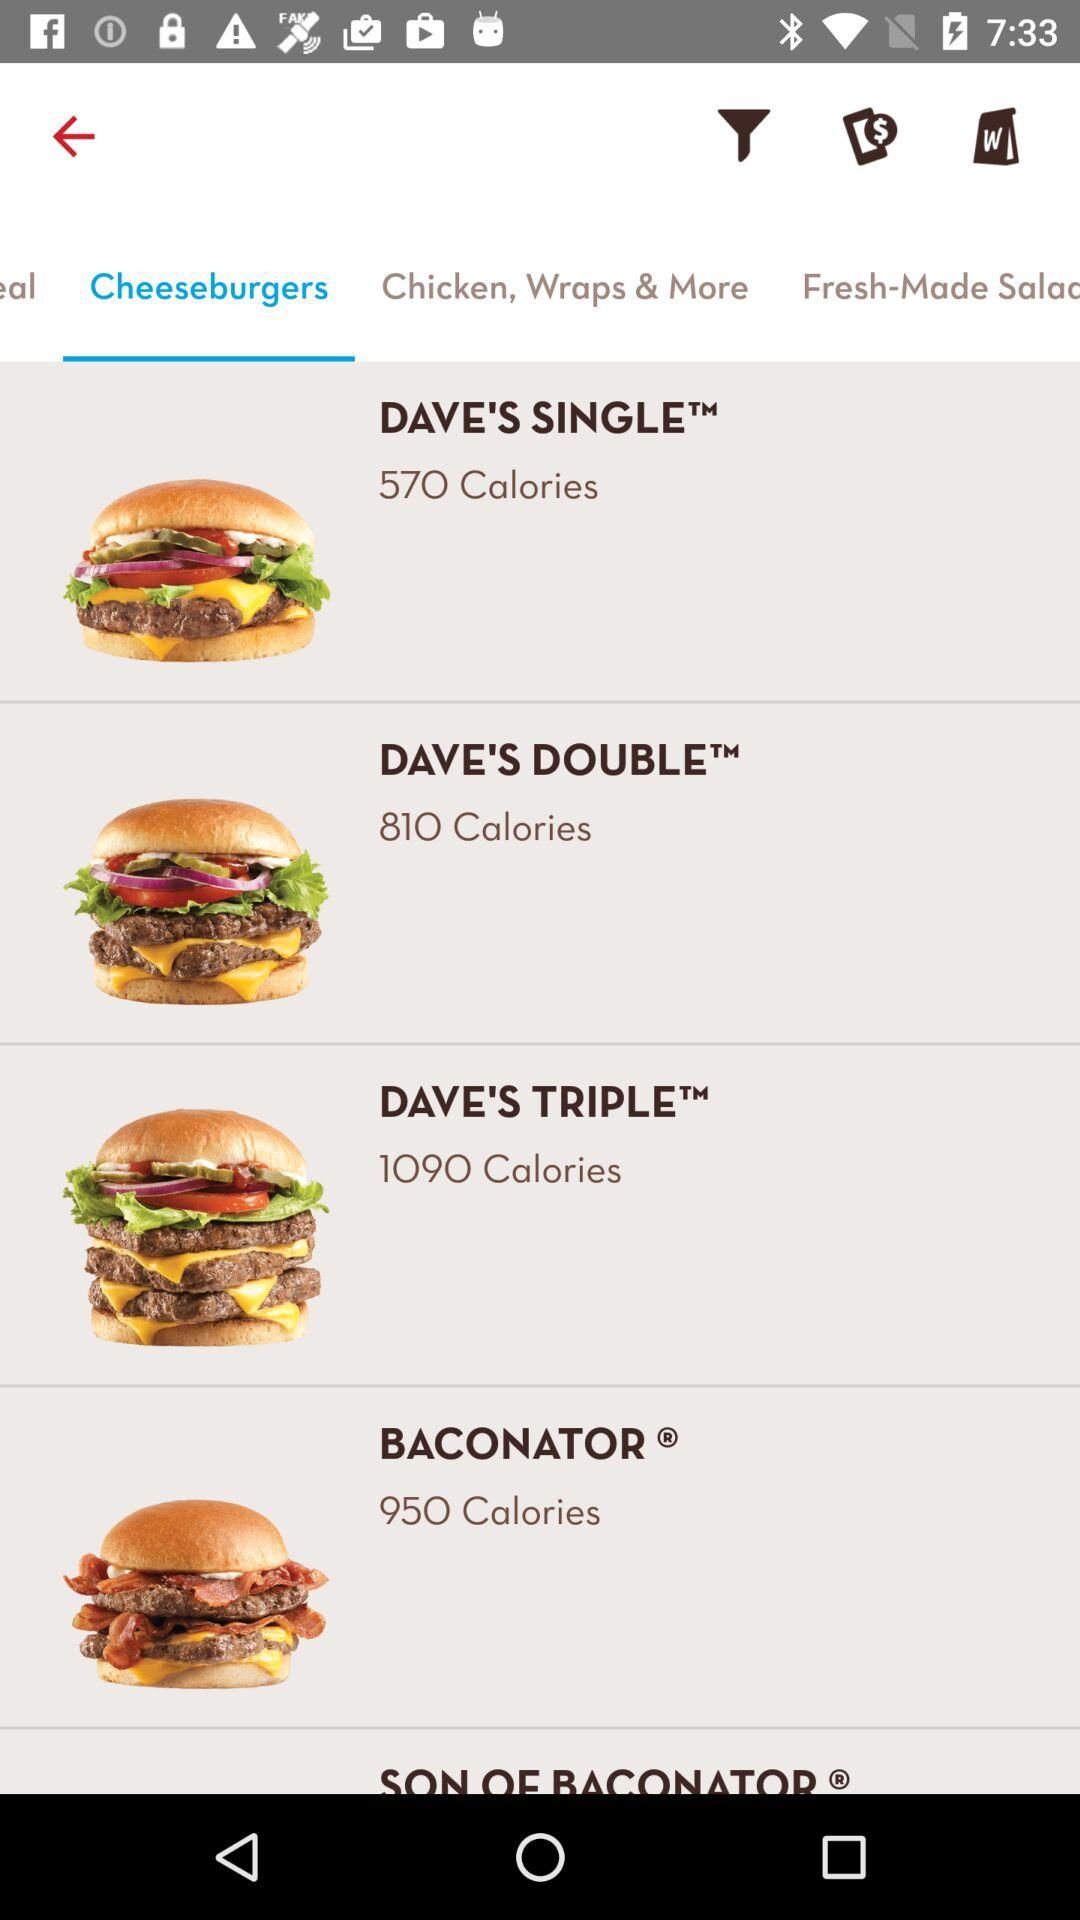How many calories are there in the Baconator cheeseburger? There are 950 calories in the Baconator cheeseburger. 